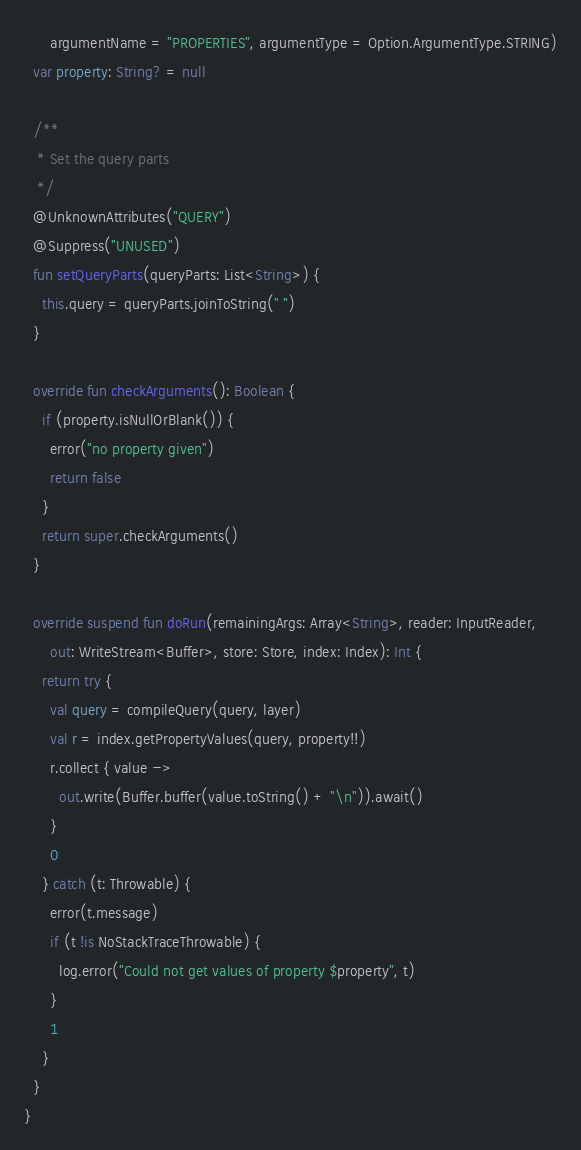Convert code to text. <code><loc_0><loc_0><loc_500><loc_500><_Kotlin_>      argumentName = "PROPERTIES", argumentType = Option.ArgumentType.STRING)
  var property: String? = null

  /**
   * Set the query parts
   */
  @UnknownAttributes("QUERY")
  @Suppress("UNUSED")
  fun setQueryParts(queryParts: List<String>) {
    this.query = queryParts.joinToString(" ")
  }

  override fun checkArguments(): Boolean {
    if (property.isNullOrBlank()) {
      error("no property given")
      return false
    }
    return super.checkArguments()
  }

  override suspend fun doRun(remainingArgs: Array<String>, reader: InputReader,
      out: WriteStream<Buffer>, store: Store, index: Index): Int {
    return try {
      val query = compileQuery(query, layer)
      val r = index.getPropertyValues(query, property!!)
      r.collect { value ->
        out.write(Buffer.buffer(value.toString() + "\n")).await()
      }
      0
    } catch (t: Throwable) {
      error(t.message)
      if (t !is NoStackTraceThrowable) {
        log.error("Could not get values of property $property", t)
      }
      1
    }
  }
}
</code> 